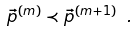Convert formula to latex. <formula><loc_0><loc_0><loc_500><loc_500>\vec { p } ^ { ( m ) } \prec \vec { p } ^ { ( m + 1 ) } \ .</formula> 